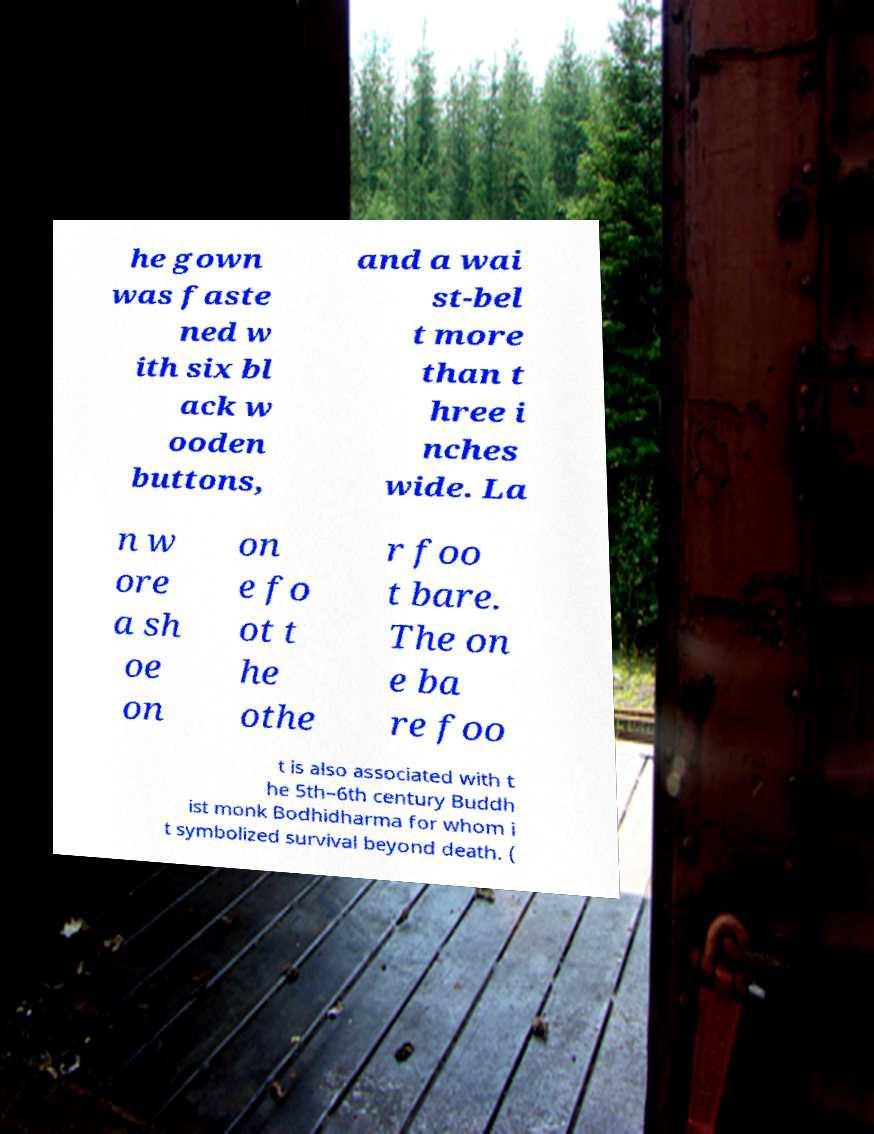There's text embedded in this image that I need extracted. Can you transcribe it verbatim? he gown was faste ned w ith six bl ack w ooden buttons, and a wai st-bel t more than t hree i nches wide. La n w ore a sh oe on on e fo ot t he othe r foo t bare. The on e ba re foo t is also associated with t he 5th–6th century Buddh ist monk Bodhidharma for whom i t symbolized survival beyond death. ( 